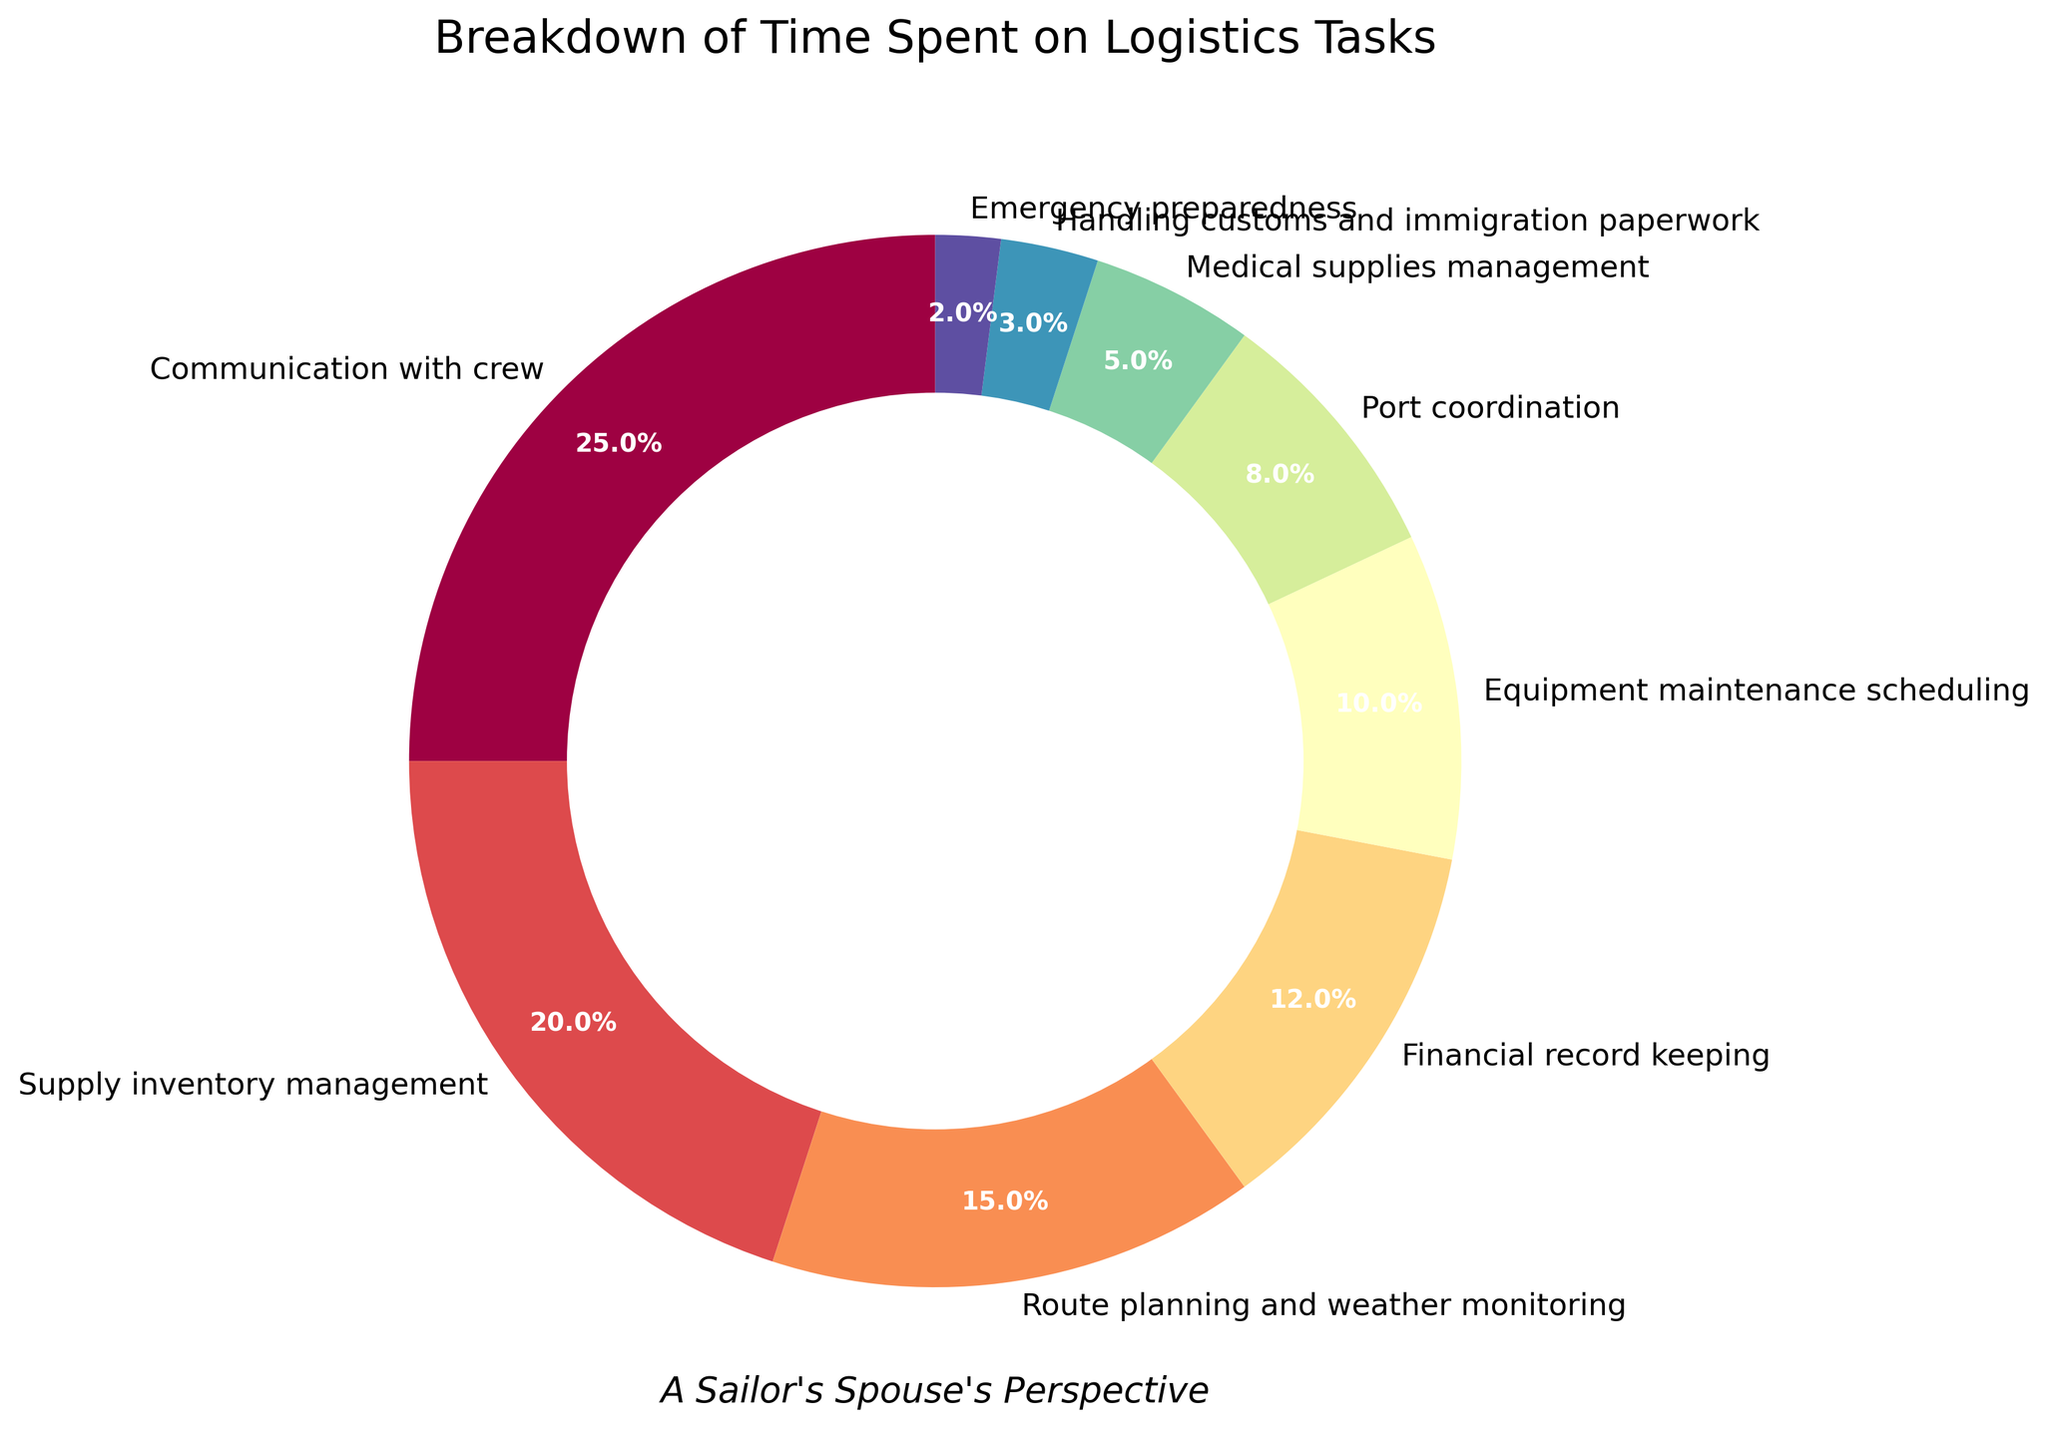What is the largest segment in the pie chart? The largest segment is the one with the highest percentage, which can be identified visually as the segment that occupies the largest area. By examining the pie chart, the "Communication with crew" segment is the largest.
Answer: Communication with crew What is the combined percentage of time spent on Financial record keeping and Equipment maintenance scheduling? To find the combined percentage, add the percentages of both tasks. Financial record keeping is 12% and Equipment maintenance scheduling is 10%, so the total is 12% + 10% = 22%.
Answer: 22% Which task takes up less time: Port coordination or Handling customs and immigration paperwork? Compare the percentages of each task. Port coordination is 8% and Handling customs and immigration paperwork is 3%. Since 3% is less than 8%, Handling customs and immigration paperwork takes up less time.
Answer: Handling customs and immigration paperwork How much more time is spent on Communication with crew compared to Emergency preparedness? Subtract the percentage of time spent on Emergency preparedness from the percentage of time spent on Communication with crew. Communication with crew is 25% and Emergency preparedness is 2%, so the difference is 25% - 2% = 23%.
Answer: 23% What is the average percentage of time spent on Route planning and weather monitoring, Port coordination, and Medical supplies management? Calculate the average by summing the percentages and dividing by the number of tasks. Route planning and weather monitoring is 15%, Port coordination is 8%, Medical supplies management is 5%. So, the average is (15% + 8% + 5%) / 3 = 28% / 3 ≈ 9.33%.
Answer: 9.33% Which color represents the task of Supply inventory management in the pie chart? Identify the segment that is labeled as "Supply inventory management" and note its color visually. Since the exact color names are not specified in the data or code snippet, you would refer to the visually observed color in the plot for this answer. Assuming the segment is easiest to identify, state its color directly.
Answer: (Assumed response based on observation) Orange What is the difference in the time spent on Medical supplies management and Emergency preparedness? Subtract the percentage of Emergency preparedness from Medical supplies management. Medical supplies management is 5% and Emergency preparedness is 2%, so the difference is 5% - 2% = 3%.
Answer: 3% How many tasks occupy more than 10% of the total time each? Count the number of segments that each represent more than 10% of the total pie chart. Communication with crew (25%), Supply inventory management (20%), Route planning and weather monitoring (15%), and Financial record keeping (12%) each are more than 10%. So, there are 4 such tasks.
Answer: 4 Which tasks together account for over 50% of the total time? Add up the percentages of tasks starting from the largest until the combined total exceeds 50%. Communication with crew (25%), Supply inventory management (20%), and Route planning and weather monitoring (15%) sum up to 25% + 20% + 15% = 60%. This is more than 50%. Hence, these three tasks together account for over 50%.
Answer: Communication with crew, Supply inventory management, Route planning and weather monitoring 